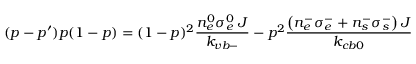<formula> <loc_0><loc_0><loc_500><loc_500>( p - p ^ { \prime } ) p ( 1 - p ) = ( 1 - p ) ^ { 2 } \frac { n _ { e } ^ { 0 } \sigma _ { e } ^ { 0 } \, J } { k _ { v b - } } - p ^ { 2 } \frac { \left ( n _ { e } ^ { - } \sigma _ { e } ^ { - } + n _ { s } ^ { - } \sigma _ { s } ^ { - } \right ) J } { k _ { c b 0 } }</formula> 